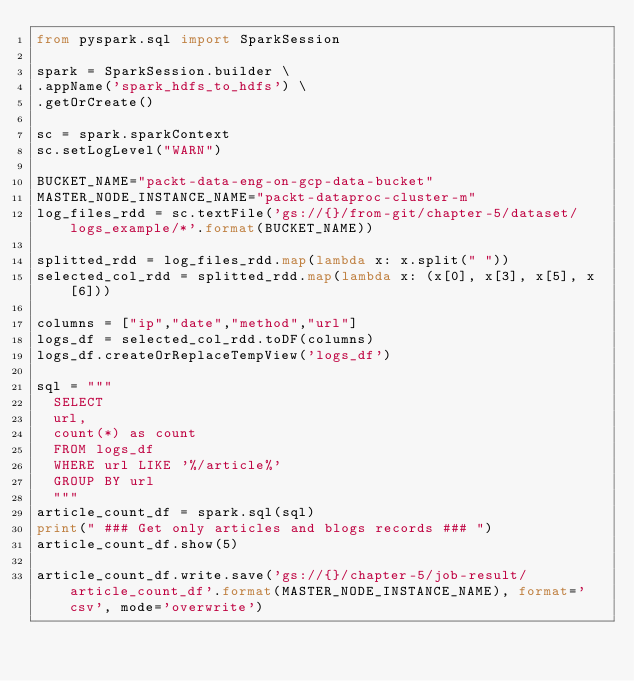<code> <loc_0><loc_0><loc_500><loc_500><_Python_>from pyspark.sql import SparkSession

spark = SparkSession.builder \
.appName('spark_hdfs_to_hdfs') \
.getOrCreate()

sc = spark.sparkContext
sc.setLogLevel("WARN")

BUCKET_NAME="packt-data-eng-on-gcp-data-bucket"
MASTER_NODE_INSTANCE_NAME="packt-dataproc-cluster-m"
log_files_rdd = sc.textFile('gs://{}/from-git/chapter-5/dataset/logs_example/*'.format(BUCKET_NAME))

splitted_rdd = log_files_rdd.map(lambda x: x.split(" "))
selected_col_rdd = splitted_rdd.map(lambda x: (x[0], x[3], x[5], x[6]))

columns = ["ip","date","method","url"]
logs_df = selected_col_rdd.toDF(columns)
logs_df.createOrReplaceTempView('logs_df')

sql = """
  SELECT
  url,
  count(*) as count
  FROM logs_df
  WHERE url LIKE '%/article%'
  GROUP BY url
  """
article_count_df = spark.sql(sql)
print(" ### Get only articles and blogs records ### ")
article_count_df.show(5)

article_count_df.write.save('gs://{}/chapter-5/job-result/article_count_df'.format(MASTER_NODE_INSTANCE_NAME), format='csv', mode='overwrite')
</code> 